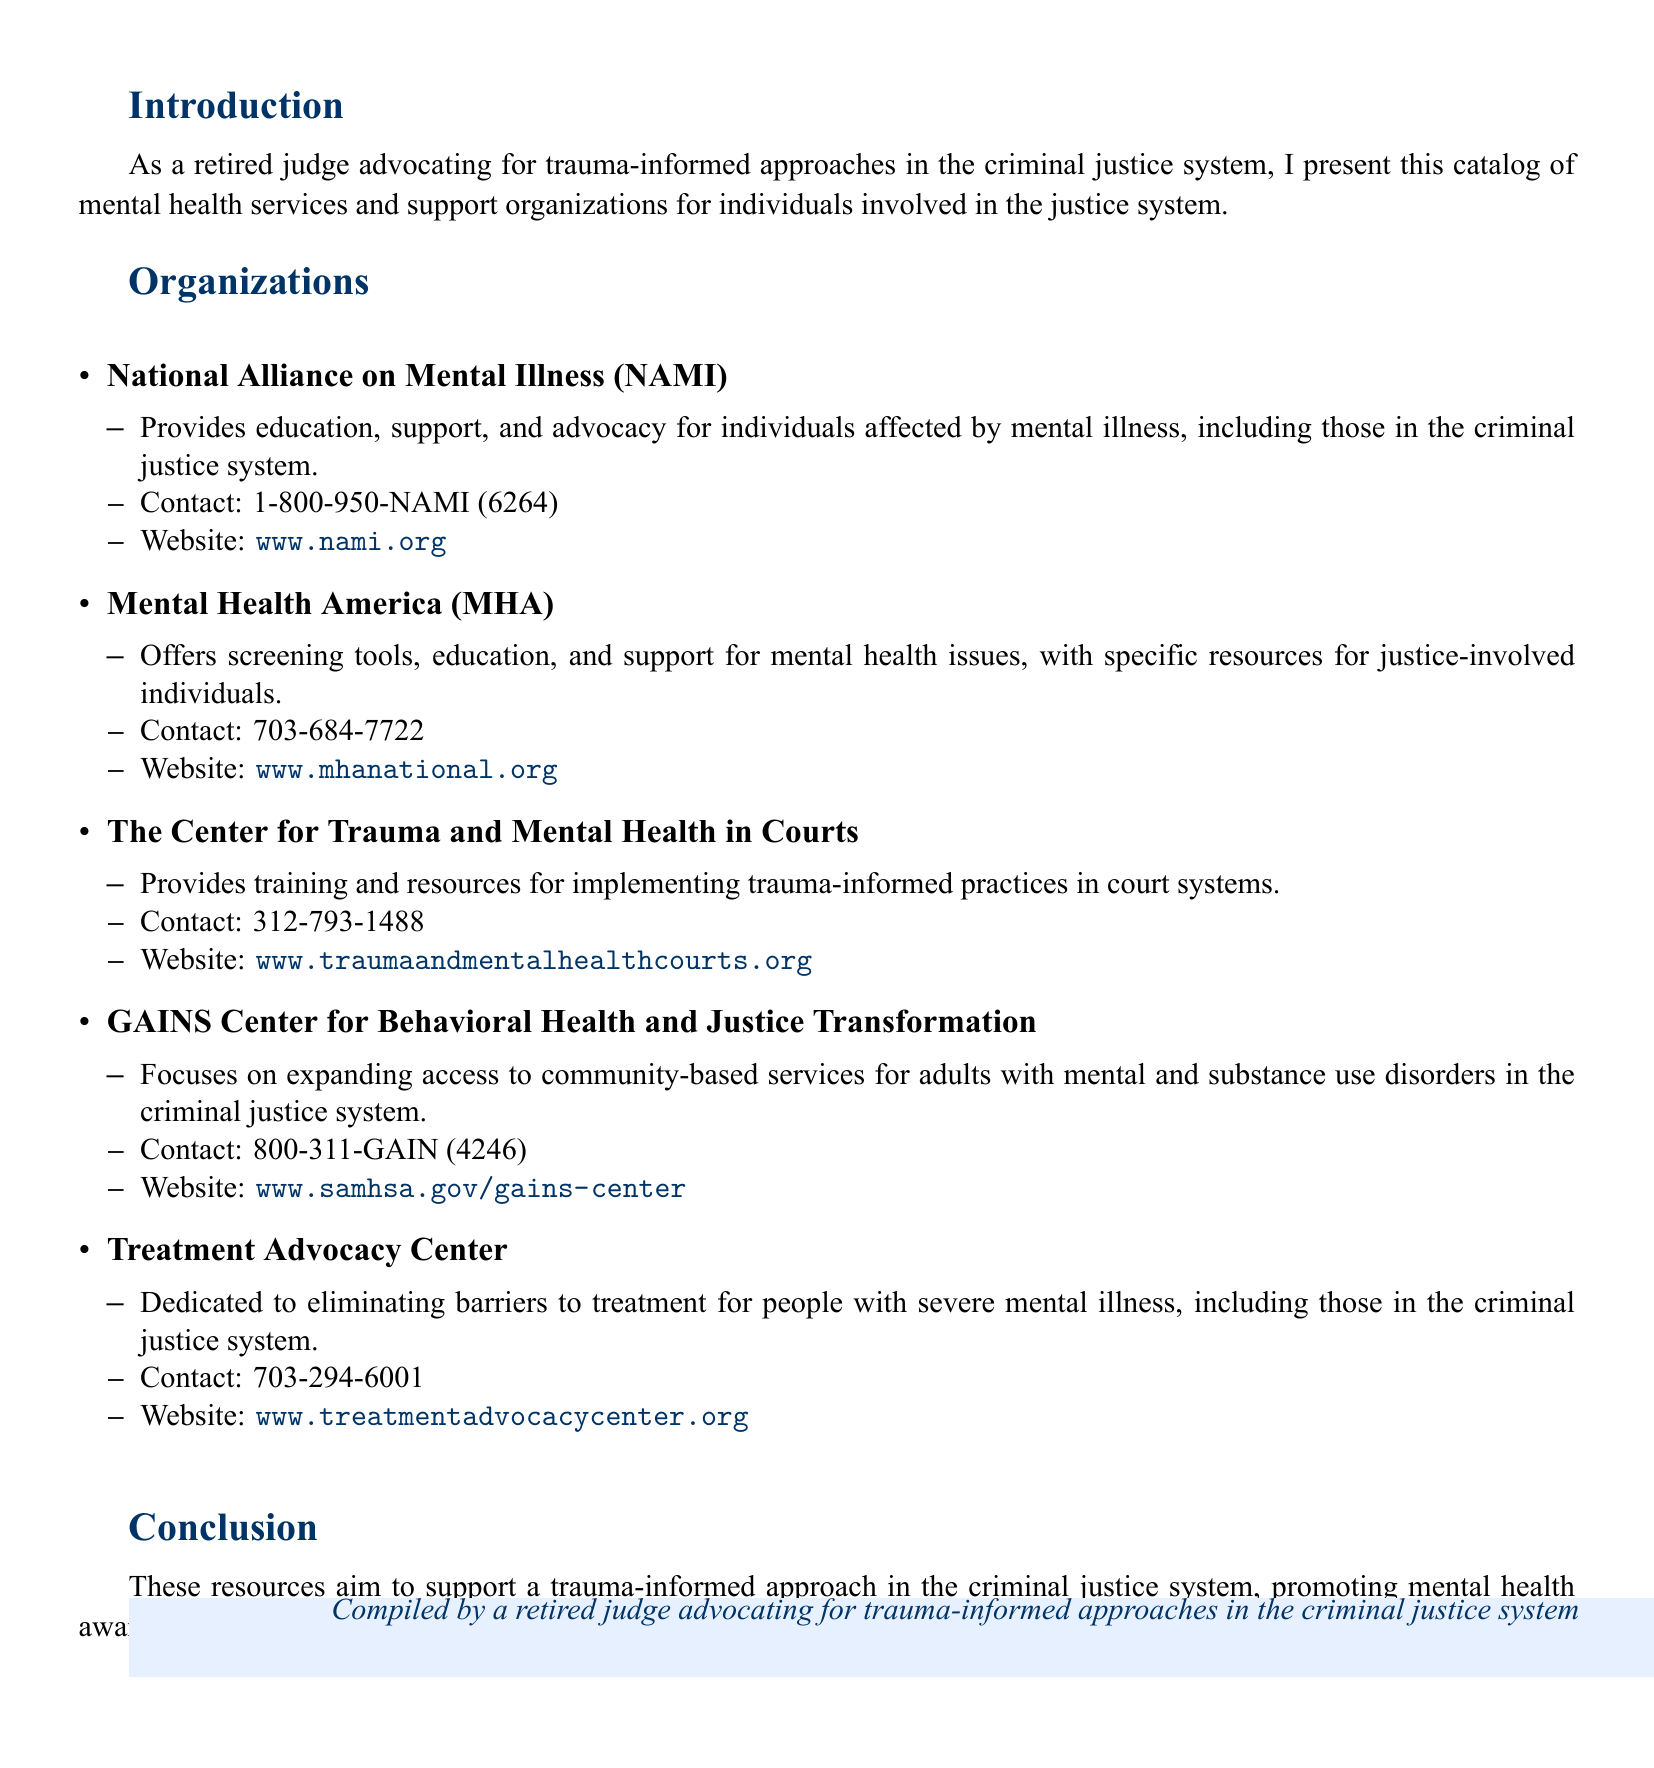What is the main purpose of this catalog? The catalog presents mental health services and support organizations for individuals involved in the justice system.
Answer: Support organizations How many organizations are listed in the document? The document lists five organizations.
Answer: Five What is the contact number for the National Alliance on Mental Illness? The contact number for NAMI is provided in the document.
Answer: 1-800-950-NAMI (6264) Which organization focuses on trauma-informed practices in court systems? The document specifies that one organization provides training and resources for trauma-informed practices.
Answer: The Center for Trauma and Mental Health in Courts What type of services does the GAINS Center focus on expanding? The GAINS Center focuses on expanding access to community-based services.
Answer: Community-based services What is the website for the Treatment Advocacy Center? The document includes the web address for the Treatment Advocacy Center.
Answer: www.treatmentadvocacycenter.org What is the primary issue addressed by the Treatment Advocacy Center? The document describes the main focus of the Treatment Advocacy Center regarding mental illness treatment.
Answer: Eliminating barriers to treatment How does the catalog aim to support justice-involved individuals? The document states how the resources support individuals in the context of trauma-informed approaches.
Answer: Promoting mental health awareness and treatment Who compiled this resource catalog? The document provides the role of the person who compiled the catalog.
Answer: A retired judge 